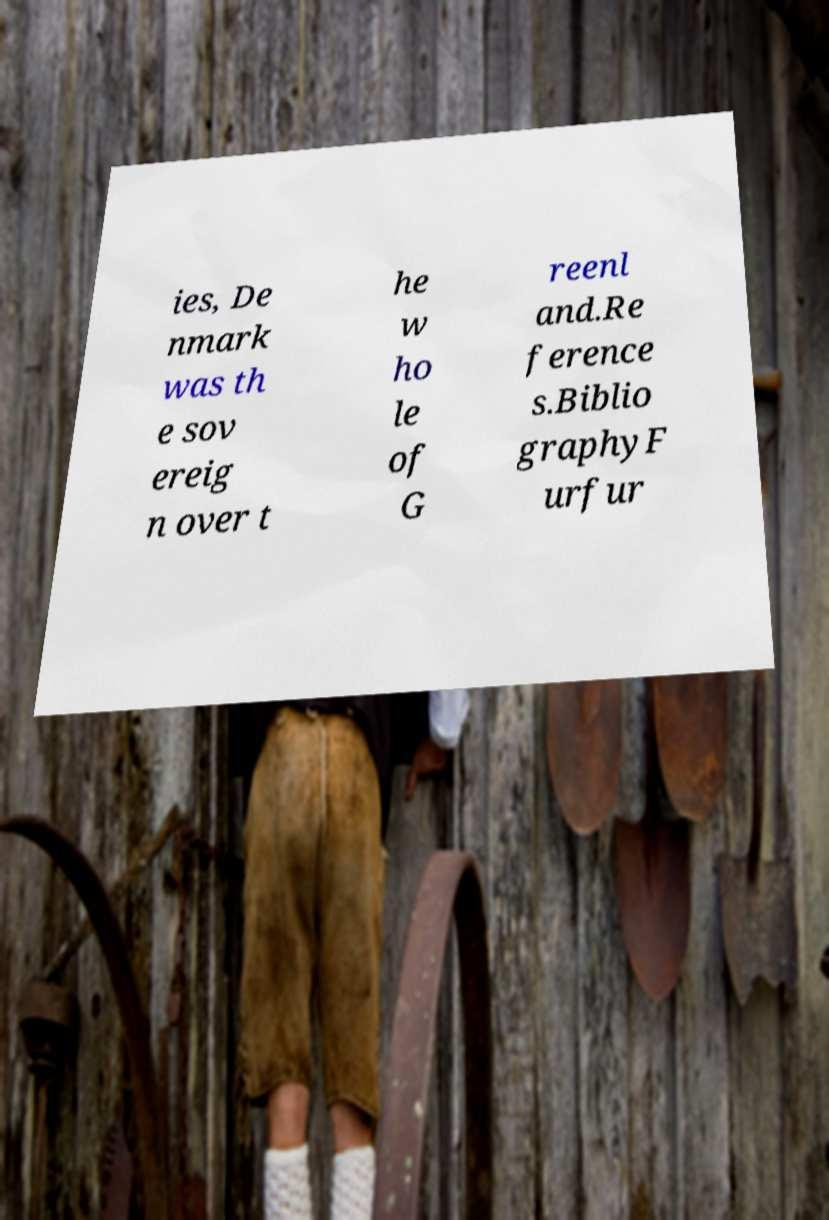There's text embedded in this image that I need extracted. Can you transcribe it verbatim? ies, De nmark was th e sov ereig n over t he w ho le of G reenl and.Re ference s.Biblio graphyF urfur 